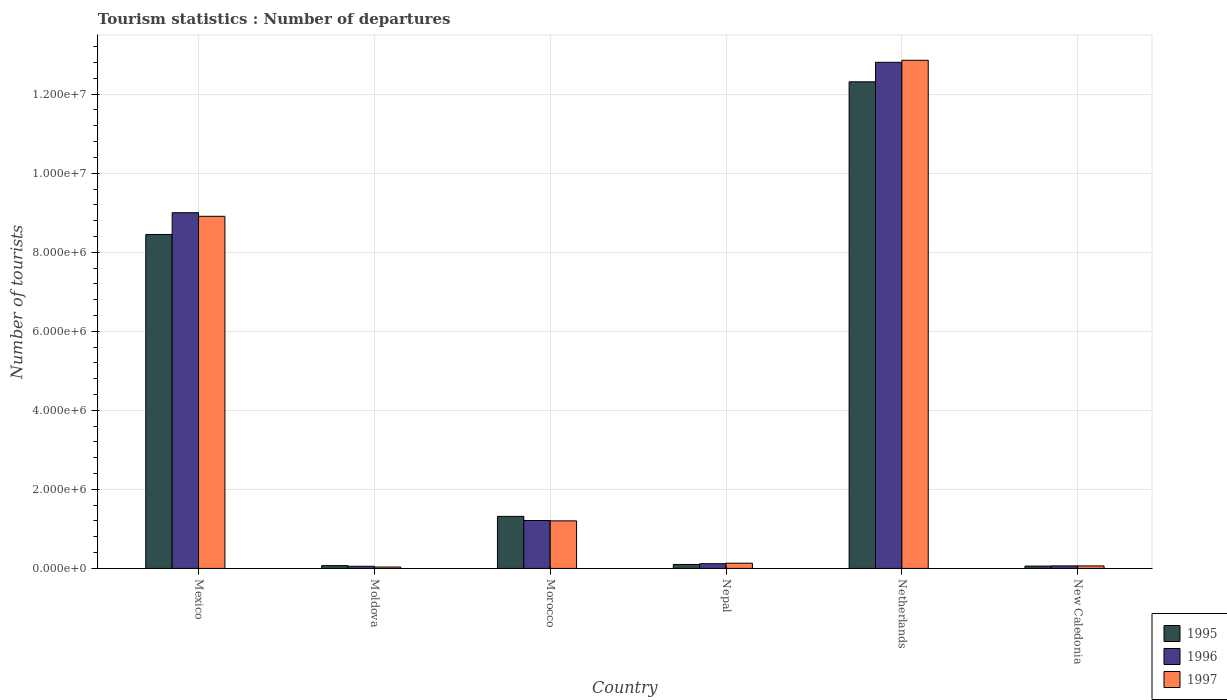How many groups of bars are there?
Your answer should be very brief. 6. Are the number of bars per tick equal to the number of legend labels?
Your answer should be very brief. Yes. How many bars are there on the 3rd tick from the left?
Your response must be concise. 3. What is the label of the 2nd group of bars from the left?
Provide a short and direct response. Moldova. In how many cases, is the number of bars for a given country not equal to the number of legend labels?
Ensure brevity in your answer.  0. What is the number of tourist departures in 1997 in Nepal?
Your answer should be very brief. 1.32e+05. Across all countries, what is the maximum number of tourist departures in 1996?
Ensure brevity in your answer.  1.28e+07. Across all countries, what is the minimum number of tourist departures in 1995?
Keep it short and to the point. 5.90e+04. In which country was the number of tourist departures in 1996 minimum?
Provide a short and direct response. Moldova. What is the total number of tourist departures in 1995 in the graph?
Your response must be concise. 2.23e+07. What is the difference between the number of tourist departures in 1995 in Moldova and that in New Caledonia?
Provide a succinct answer. 1.20e+04. What is the difference between the number of tourist departures in 1997 in New Caledonia and the number of tourist departures in 1995 in Nepal?
Ensure brevity in your answer.  -3.70e+04. What is the average number of tourist departures in 1997 per country?
Offer a terse response. 3.87e+06. What is the difference between the number of tourist departures of/in 1995 and number of tourist departures of/in 1997 in Nepal?
Make the answer very short. -3.20e+04. What is the ratio of the number of tourist departures in 1996 in Moldova to that in New Caledonia?
Provide a succinct answer. 0.84. Is the difference between the number of tourist departures in 1995 in Netherlands and New Caledonia greater than the difference between the number of tourist departures in 1997 in Netherlands and New Caledonia?
Your answer should be compact. No. What is the difference between the highest and the second highest number of tourist departures in 1995?
Make the answer very short. 1.10e+07. What is the difference between the highest and the lowest number of tourist departures in 1997?
Offer a terse response. 1.28e+07. Is the sum of the number of tourist departures in 1997 in Mexico and Moldova greater than the maximum number of tourist departures in 1996 across all countries?
Offer a very short reply. No. What does the 1st bar from the right in Mexico represents?
Ensure brevity in your answer.  1997. Is it the case that in every country, the sum of the number of tourist departures in 1995 and number of tourist departures in 1996 is greater than the number of tourist departures in 1997?
Provide a short and direct response. Yes. How many bars are there?
Ensure brevity in your answer.  18. Does the graph contain grids?
Your answer should be very brief. Yes. How many legend labels are there?
Ensure brevity in your answer.  3. How are the legend labels stacked?
Your answer should be very brief. Vertical. What is the title of the graph?
Give a very brief answer. Tourism statistics : Number of departures. Does "1972" appear as one of the legend labels in the graph?
Offer a very short reply. No. What is the label or title of the Y-axis?
Your answer should be compact. Number of tourists. What is the Number of tourists in 1995 in Mexico?
Keep it short and to the point. 8.45e+06. What is the Number of tourists in 1996 in Mexico?
Give a very brief answer. 9.00e+06. What is the Number of tourists of 1997 in Mexico?
Your answer should be very brief. 8.91e+06. What is the Number of tourists in 1995 in Moldova?
Provide a short and direct response. 7.10e+04. What is the Number of tourists of 1996 in Moldova?
Give a very brief answer. 5.40e+04. What is the Number of tourists of 1997 in Moldova?
Your answer should be very brief. 3.50e+04. What is the Number of tourists of 1995 in Morocco?
Offer a terse response. 1.32e+06. What is the Number of tourists of 1996 in Morocco?
Keep it short and to the point. 1.21e+06. What is the Number of tourists of 1997 in Morocco?
Ensure brevity in your answer.  1.20e+06. What is the Number of tourists of 1995 in Nepal?
Keep it short and to the point. 1.00e+05. What is the Number of tourists in 1996 in Nepal?
Offer a very short reply. 1.19e+05. What is the Number of tourists in 1997 in Nepal?
Ensure brevity in your answer.  1.32e+05. What is the Number of tourists in 1995 in Netherlands?
Provide a succinct answer. 1.23e+07. What is the Number of tourists in 1996 in Netherlands?
Ensure brevity in your answer.  1.28e+07. What is the Number of tourists in 1997 in Netherlands?
Provide a short and direct response. 1.29e+07. What is the Number of tourists of 1995 in New Caledonia?
Your answer should be very brief. 5.90e+04. What is the Number of tourists of 1996 in New Caledonia?
Offer a very short reply. 6.40e+04. What is the Number of tourists of 1997 in New Caledonia?
Offer a very short reply. 6.30e+04. Across all countries, what is the maximum Number of tourists in 1995?
Provide a succinct answer. 1.23e+07. Across all countries, what is the maximum Number of tourists in 1996?
Give a very brief answer. 1.28e+07. Across all countries, what is the maximum Number of tourists in 1997?
Your response must be concise. 1.29e+07. Across all countries, what is the minimum Number of tourists of 1995?
Ensure brevity in your answer.  5.90e+04. Across all countries, what is the minimum Number of tourists of 1996?
Offer a very short reply. 5.40e+04. Across all countries, what is the minimum Number of tourists in 1997?
Give a very brief answer. 3.50e+04. What is the total Number of tourists of 1995 in the graph?
Keep it short and to the point. 2.23e+07. What is the total Number of tourists in 1996 in the graph?
Provide a succinct answer. 2.33e+07. What is the total Number of tourists of 1997 in the graph?
Your answer should be compact. 2.32e+07. What is the difference between the Number of tourists in 1995 in Mexico and that in Moldova?
Ensure brevity in your answer.  8.38e+06. What is the difference between the Number of tourists in 1996 in Mexico and that in Moldova?
Give a very brief answer. 8.95e+06. What is the difference between the Number of tourists of 1997 in Mexico and that in Moldova?
Provide a short and direct response. 8.88e+06. What is the difference between the Number of tourists in 1995 in Mexico and that in Morocco?
Provide a short and direct response. 7.13e+06. What is the difference between the Number of tourists of 1996 in Mexico and that in Morocco?
Ensure brevity in your answer.  7.79e+06. What is the difference between the Number of tourists of 1997 in Mexico and that in Morocco?
Keep it short and to the point. 7.71e+06. What is the difference between the Number of tourists in 1995 in Mexico and that in Nepal?
Make the answer very short. 8.35e+06. What is the difference between the Number of tourists in 1996 in Mexico and that in Nepal?
Give a very brief answer. 8.88e+06. What is the difference between the Number of tourists in 1997 in Mexico and that in Nepal?
Provide a short and direct response. 8.78e+06. What is the difference between the Number of tourists of 1995 in Mexico and that in Netherlands?
Provide a short and direct response. -3.86e+06. What is the difference between the Number of tourists in 1996 in Mexico and that in Netherlands?
Your answer should be compact. -3.81e+06. What is the difference between the Number of tourists of 1997 in Mexico and that in Netherlands?
Offer a terse response. -3.95e+06. What is the difference between the Number of tourists in 1995 in Mexico and that in New Caledonia?
Offer a terse response. 8.39e+06. What is the difference between the Number of tourists of 1996 in Mexico and that in New Caledonia?
Ensure brevity in your answer.  8.94e+06. What is the difference between the Number of tourists in 1997 in Mexico and that in New Caledonia?
Keep it short and to the point. 8.85e+06. What is the difference between the Number of tourists in 1995 in Moldova and that in Morocco?
Your answer should be very brief. -1.25e+06. What is the difference between the Number of tourists in 1996 in Moldova and that in Morocco?
Your answer should be very brief. -1.16e+06. What is the difference between the Number of tourists of 1997 in Moldova and that in Morocco?
Your response must be concise. -1.17e+06. What is the difference between the Number of tourists of 1995 in Moldova and that in Nepal?
Offer a very short reply. -2.90e+04. What is the difference between the Number of tourists of 1996 in Moldova and that in Nepal?
Give a very brief answer. -6.50e+04. What is the difference between the Number of tourists in 1997 in Moldova and that in Nepal?
Offer a very short reply. -9.70e+04. What is the difference between the Number of tourists in 1995 in Moldova and that in Netherlands?
Your answer should be compact. -1.22e+07. What is the difference between the Number of tourists in 1996 in Moldova and that in Netherlands?
Your response must be concise. -1.28e+07. What is the difference between the Number of tourists of 1997 in Moldova and that in Netherlands?
Give a very brief answer. -1.28e+07. What is the difference between the Number of tourists in 1995 in Moldova and that in New Caledonia?
Your answer should be very brief. 1.20e+04. What is the difference between the Number of tourists in 1996 in Moldova and that in New Caledonia?
Offer a terse response. -10000. What is the difference between the Number of tourists of 1997 in Moldova and that in New Caledonia?
Give a very brief answer. -2.80e+04. What is the difference between the Number of tourists of 1995 in Morocco and that in Nepal?
Your response must be concise. 1.22e+06. What is the difference between the Number of tourists of 1996 in Morocco and that in Nepal?
Provide a short and direct response. 1.09e+06. What is the difference between the Number of tourists of 1997 in Morocco and that in Nepal?
Make the answer very short. 1.07e+06. What is the difference between the Number of tourists of 1995 in Morocco and that in Netherlands?
Provide a short and direct response. -1.10e+07. What is the difference between the Number of tourists of 1996 in Morocco and that in Netherlands?
Ensure brevity in your answer.  -1.16e+07. What is the difference between the Number of tourists in 1997 in Morocco and that in Netherlands?
Make the answer very short. -1.17e+07. What is the difference between the Number of tourists of 1995 in Morocco and that in New Caledonia?
Provide a succinct answer. 1.26e+06. What is the difference between the Number of tourists in 1996 in Morocco and that in New Caledonia?
Your answer should be very brief. 1.15e+06. What is the difference between the Number of tourists of 1997 in Morocco and that in New Caledonia?
Offer a terse response. 1.14e+06. What is the difference between the Number of tourists in 1995 in Nepal and that in Netherlands?
Your response must be concise. -1.22e+07. What is the difference between the Number of tourists in 1996 in Nepal and that in Netherlands?
Offer a very short reply. -1.27e+07. What is the difference between the Number of tourists in 1997 in Nepal and that in Netherlands?
Ensure brevity in your answer.  -1.27e+07. What is the difference between the Number of tourists in 1995 in Nepal and that in New Caledonia?
Provide a short and direct response. 4.10e+04. What is the difference between the Number of tourists of 1996 in Nepal and that in New Caledonia?
Give a very brief answer. 5.50e+04. What is the difference between the Number of tourists of 1997 in Nepal and that in New Caledonia?
Give a very brief answer. 6.90e+04. What is the difference between the Number of tourists in 1995 in Netherlands and that in New Caledonia?
Provide a succinct answer. 1.23e+07. What is the difference between the Number of tourists in 1996 in Netherlands and that in New Caledonia?
Provide a short and direct response. 1.27e+07. What is the difference between the Number of tourists of 1997 in Netherlands and that in New Caledonia?
Provide a succinct answer. 1.28e+07. What is the difference between the Number of tourists in 1995 in Mexico and the Number of tourists in 1996 in Moldova?
Make the answer very short. 8.40e+06. What is the difference between the Number of tourists in 1995 in Mexico and the Number of tourists in 1997 in Moldova?
Keep it short and to the point. 8.42e+06. What is the difference between the Number of tourists of 1996 in Mexico and the Number of tourists of 1997 in Moldova?
Offer a terse response. 8.97e+06. What is the difference between the Number of tourists in 1995 in Mexico and the Number of tourists in 1996 in Morocco?
Your answer should be compact. 7.24e+06. What is the difference between the Number of tourists of 1995 in Mexico and the Number of tourists of 1997 in Morocco?
Your response must be concise. 7.25e+06. What is the difference between the Number of tourists in 1996 in Mexico and the Number of tourists in 1997 in Morocco?
Keep it short and to the point. 7.80e+06. What is the difference between the Number of tourists in 1995 in Mexico and the Number of tourists in 1996 in Nepal?
Your answer should be very brief. 8.33e+06. What is the difference between the Number of tourists of 1995 in Mexico and the Number of tourists of 1997 in Nepal?
Your response must be concise. 8.32e+06. What is the difference between the Number of tourists of 1996 in Mexico and the Number of tourists of 1997 in Nepal?
Your answer should be very brief. 8.87e+06. What is the difference between the Number of tourists in 1995 in Mexico and the Number of tourists in 1996 in Netherlands?
Keep it short and to the point. -4.36e+06. What is the difference between the Number of tourists of 1995 in Mexico and the Number of tourists of 1997 in Netherlands?
Offer a very short reply. -4.41e+06. What is the difference between the Number of tourists in 1996 in Mexico and the Number of tourists in 1997 in Netherlands?
Your answer should be compact. -3.86e+06. What is the difference between the Number of tourists in 1995 in Mexico and the Number of tourists in 1996 in New Caledonia?
Keep it short and to the point. 8.39e+06. What is the difference between the Number of tourists of 1995 in Mexico and the Number of tourists of 1997 in New Caledonia?
Ensure brevity in your answer.  8.39e+06. What is the difference between the Number of tourists in 1996 in Mexico and the Number of tourists in 1997 in New Caledonia?
Give a very brief answer. 8.94e+06. What is the difference between the Number of tourists of 1995 in Moldova and the Number of tourists of 1996 in Morocco?
Give a very brief answer. -1.14e+06. What is the difference between the Number of tourists of 1995 in Moldova and the Number of tourists of 1997 in Morocco?
Ensure brevity in your answer.  -1.13e+06. What is the difference between the Number of tourists in 1996 in Moldova and the Number of tourists in 1997 in Morocco?
Your answer should be compact. -1.15e+06. What is the difference between the Number of tourists in 1995 in Moldova and the Number of tourists in 1996 in Nepal?
Your answer should be compact. -4.80e+04. What is the difference between the Number of tourists of 1995 in Moldova and the Number of tourists of 1997 in Nepal?
Your answer should be compact. -6.10e+04. What is the difference between the Number of tourists in 1996 in Moldova and the Number of tourists in 1997 in Nepal?
Offer a very short reply. -7.80e+04. What is the difference between the Number of tourists of 1995 in Moldova and the Number of tourists of 1996 in Netherlands?
Your response must be concise. -1.27e+07. What is the difference between the Number of tourists in 1995 in Moldova and the Number of tourists in 1997 in Netherlands?
Make the answer very short. -1.28e+07. What is the difference between the Number of tourists of 1996 in Moldova and the Number of tourists of 1997 in Netherlands?
Keep it short and to the point. -1.28e+07. What is the difference between the Number of tourists of 1995 in Moldova and the Number of tourists of 1996 in New Caledonia?
Your answer should be very brief. 7000. What is the difference between the Number of tourists of 1995 in Moldova and the Number of tourists of 1997 in New Caledonia?
Provide a succinct answer. 8000. What is the difference between the Number of tourists of 1996 in Moldova and the Number of tourists of 1997 in New Caledonia?
Your answer should be very brief. -9000. What is the difference between the Number of tourists of 1995 in Morocco and the Number of tourists of 1996 in Nepal?
Keep it short and to the point. 1.20e+06. What is the difference between the Number of tourists of 1995 in Morocco and the Number of tourists of 1997 in Nepal?
Make the answer very short. 1.18e+06. What is the difference between the Number of tourists in 1996 in Morocco and the Number of tourists in 1997 in Nepal?
Your answer should be compact. 1.08e+06. What is the difference between the Number of tourists of 1995 in Morocco and the Number of tourists of 1996 in Netherlands?
Your response must be concise. -1.15e+07. What is the difference between the Number of tourists of 1995 in Morocco and the Number of tourists of 1997 in Netherlands?
Keep it short and to the point. -1.15e+07. What is the difference between the Number of tourists of 1996 in Morocco and the Number of tourists of 1997 in Netherlands?
Give a very brief answer. -1.16e+07. What is the difference between the Number of tourists in 1995 in Morocco and the Number of tourists in 1996 in New Caledonia?
Keep it short and to the point. 1.25e+06. What is the difference between the Number of tourists of 1995 in Morocco and the Number of tourists of 1997 in New Caledonia?
Give a very brief answer. 1.25e+06. What is the difference between the Number of tourists of 1996 in Morocco and the Number of tourists of 1997 in New Caledonia?
Offer a very short reply. 1.15e+06. What is the difference between the Number of tourists of 1995 in Nepal and the Number of tourists of 1996 in Netherlands?
Your answer should be compact. -1.27e+07. What is the difference between the Number of tourists of 1995 in Nepal and the Number of tourists of 1997 in Netherlands?
Your answer should be compact. -1.28e+07. What is the difference between the Number of tourists in 1996 in Nepal and the Number of tourists in 1997 in Netherlands?
Keep it short and to the point. -1.27e+07. What is the difference between the Number of tourists of 1995 in Nepal and the Number of tourists of 1996 in New Caledonia?
Your answer should be very brief. 3.60e+04. What is the difference between the Number of tourists of 1995 in Nepal and the Number of tourists of 1997 in New Caledonia?
Ensure brevity in your answer.  3.70e+04. What is the difference between the Number of tourists of 1996 in Nepal and the Number of tourists of 1997 in New Caledonia?
Provide a succinct answer. 5.60e+04. What is the difference between the Number of tourists of 1995 in Netherlands and the Number of tourists of 1996 in New Caledonia?
Keep it short and to the point. 1.22e+07. What is the difference between the Number of tourists of 1995 in Netherlands and the Number of tourists of 1997 in New Caledonia?
Provide a short and direct response. 1.22e+07. What is the difference between the Number of tourists of 1996 in Netherlands and the Number of tourists of 1997 in New Caledonia?
Offer a very short reply. 1.27e+07. What is the average Number of tourists of 1995 per country?
Provide a succinct answer. 3.72e+06. What is the average Number of tourists of 1996 per country?
Provide a succinct answer. 3.88e+06. What is the average Number of tourists in 1997 per country?
Your answer should be compact. 3.87e+06. What is the difference between the Number of tourists of 1995 and Number of tourists of 1996 in Mexico?
Your answer should be very brief. -5.51e+05. What is the difference between the Number of tourists of 1995 and Number of tourists of 1997 in Mexico?
Offer a terse response. -4.60e+05. What is the difference between the Number of tourists of 1996 and Number of tourists of 1997 in Mexico?
Give a very brief answer. 9.10e+04. What is the difference between the Number of tourists of 1995 and Number of tourists of 1996 in Moldova?
Your response must be concise. 1.70e+04. What is the difference between the Number of tourists of 1995 and Number of tourists of 1997 in Moldova?
Your answer should be very brief. 3.60e+04. What is the difference between the Number of tourists of 1996 and Number of tourists of 1997 in Moldova?
Give a very brief answer. 1.90e+04. What is the difference between the Number of tourists in 1995 and Number of tourists in 1996 in Morocco?
Offer a terse response. 1.05e+05. What is the difference between the Number of tourists of 1995 and Number of tourists of 1997 in Morocco?
Provide a short and direct response. 1.14e+05. What is the difference between the Number of tourists of 1996 and Number of tourists of 1997 in Morocco?
Provide a succinct answer. 9000. What is the difference between the Number of tourists of 1995 and Number of tourists of 1996 in Nepal?
Give a very brief answer. -1.90e+04. What is the difference between the Number of tourists in 1995 and Number of tourists in 1997 in Nepal?
Offer a very short reply. -3.20e+04. What is the difference between the Number of tourists of 1996 and Number of tourists of 1997 in Nepal?
Your answer should be compact. -1.30e+04. What is the difference between the Number of tourists in 1995 and Number of tourists in 1996 in Netherlands?
Your answer should be very brief. -4.94e+05. What is the difference between the Number of tourists of 1995 and Number of tourists of 1997 in Netherlands?
Ensure brevity in your answer.  -5.45e+05. What is the difference between the Number of tourists in 1996 and Number of tourists in 1997 in Netherlands?
Your answer should be very brief. -5.10e+04. What is the difference between the Number of tourists in 1995 and Number of tourists in 1996 in New Caledonia?
Provide a short and direct response. -5000. What is the difference between the Number of tourists in 1995 and Number of tourists in 1997 in New Caledonia?
Your answer should be compact. -4000. What is the ratio of the Number of tourists in 1995 in Mexico to that in Moldova?
Give a very brief answer. 119.01. What is the ratio of the Number of tourists in 1996 in Mexico to that in Moldova?
Offer a very short reply. 166.69. What is the ratio of the Number of tourists in 1997 in Mexico to that in Moldova?
Ensure brevity in your answer.  254.57. What is the ratio of the Number of tourists of 1995 in Mexico to that in Morocco?
Make the answer very short. 6.42. What is the ratio of the Number of tourists of 1996 in Mexico to that in Morocco?
Your answer should be compact. 7.43. What is the ratio of the Number of tourists in 1997 in Mexico to that in Morocco?
Make the answer very short. 7.41. What is the ratio of the Number of tourists in 1995 in Mexico to that in Nepal?
Provide a short and direct response. 84.5. What is the ratio of the Number of tourists in 1996 in Mexico to that in Nepal?
Your answer should be compact. 75.64. What is the ratio of the Number of tourists of 1997 in Mexico to that in Nepal?
Provide a succinct answer. 67.5. What is the ratio of the Number of tourists of 1995 in Mexico to that in Netherlands?
Offer a very short reply. 0.69. What is the ratio of the Number of tourists in 1996 in Mexico to that in Netherlands?
Your response must be concise. 0.7. What is the ratio of the Number of tourists in 1997 in Mexico to that in Netherlands?
Your answer should be compact. 0.69. What is the ratio of the Number of tourists of 1995 in Mexico to that in New Caledonia?
Your response must be concise. 143.22. What is the ratio of the Number of tourists in 1996 in Mexico to that in New Caledonia?
Keep it short and to the point. 140.64. What is the ratio of the Number of tourists in 1997 in Mexico to that in New Caledonia?
Make the answer very short. 141.43. What is the ratio of the Number of tourists of 1995 in Moldova to that in Morocco?
Keep it short and to the point. 0.05. What is the ratio of the Number of tourists of 1996 in Moldova to that in Morocco?
Keep it short and to the point. 0.04. What is the ratio of the Number of tourists of 1997 in Moldova to that in Morocco?
Your answer should be very brief. 0.03. What is the ratio of the Number of tourists in 1995 in Moldova to that in Nepal?
Provide a short and direct response. 0.71. What is the ratio of the Number of tourists of 1996 in Moldova to that in Nepal?
Provide a short and direct response. 0.45. What is the ratio of the Number of tourists of 1997 in Moldova to that in Nepal?
Your answer should be very brief. 0.27. What is the ratio of the Number of tourists in 1995 in Moldova to that in Netherlands?
Your answer should be compact. 0.01. What is the ratio of the Number of tourists in 1996 in Moldova to that in Netherlands?
Offer a very short reply. 0. What is the ratio of the Number of tourists of 1997 in Moldova to that in Netherlands?
Your answer should be very brief. 0. What is the ratio of the Number of tourists in 1995 in Moldova to that in New Caledonia?
Your response must be concise. 1.2. What is the ratio of the Number of tourists of 1996 in Moldova to that in New Caledonia?
Offer a terse response. 0.84. What is the ratio of the Number of tourists in 1997 in Moldova to that in New Caledonia?
Make the answer very short. 0.56. What is the ratio of the Number of tourists of 1995 in Morocco to that in Nepal?
Keep it short and to the point. 13.17. What is the ratio of the Number of tourists in 1996 in Morocco to that in Nepal?
Provide a short and direct response. 10.18. What is the ratio of the Number of tourists of 1997 in Morocco to that in Nepal?
Provide a short and direct response. 9.11. What is the ratio of the Number of tourists in 1995 in Morocco to that in Netherlands?
Provide a short and direct response. 0.11. What is the ratio of the Number of tourists in 1996 in Morocco to that in Netherlands?
Ensure brevity in your answer.  0.09. What is the ratio of the Number of tourists of 1997 in Morocco to that in Netherlands?
Give a very brief answer. 0.09. What is the ratio of the Number of tourists of 1995 in Morocco to that in New Caledonia?
Make the answer very short. 22.32. What is the ratio of the Number of tourists in 1996 in Morocco to that in New Caledonia?
Make the answer very short. 18.94. What is the ratio of the Number of tourists in 1997 in Morocco to that in New Caledonia?
Keep it short and to the point. 19.1. What is the ratio of the Number of tourists in 1995 in Nepal to that in Netherlands?
Ensure brevity in your answer.  0.01. What is the ratio of the Number of tourists of 1996 in Nepal to that in Netherlands?
Your answer should be compact. 0.01. What is the ratio of the Number of tourists in 1997 in Nepal to that in Netherlands?
Your answer should be compact. 0.01. What is the ratio of the Number of tourists of 1995 in Nepal to that in New Caledonia?
Offer a terse response. 1.69. What is the ratio of the Number of tourists of 1996 in Nepal to that in New Caledonia?
Make the answer very short. 1.86. What is the ratio of the Number of tourists in 1997 in Nepal to that in New Caledonia?
Provide a succinct answer. 2.1. What is the ratio of the Number of tourists in 1995 in Netherlands to that in New Caledonia?
Offer a terse response. 208.69. What is the ratio of the Number of tourists of 1996 in Netherlands to that in New Caledonia?
Offer a terse response. 200.11. What is the ratio of the Number of tourists in 1997 in Netherlands to that in New Caledonia?
Give a very brief answer. 204.1. What is the difference between the highest and the second highest Number of tourists in 1995?
Give a very brief answer. 3.86e+06. What is the difference between the highest and the second highest Number of tourists of 1996?
Your answer should be very brief. 3.81e+06. What is the difference between the highest and the second highest Number of tourists in 1997?
Ensure brevity in your answer.  3.95e+06. What is the difference between the highest and the lowest Number of tourists in 1995?
Give a very brief answer. 1.23e+07. What is the difference between the highest and the lowest Number of tourists of 1996?
Offer a terse response. 1.28e+07. What is the difference between the highest and the lowest Number of tourists in 1997?
Your response must be concise. 1.28e+07. 